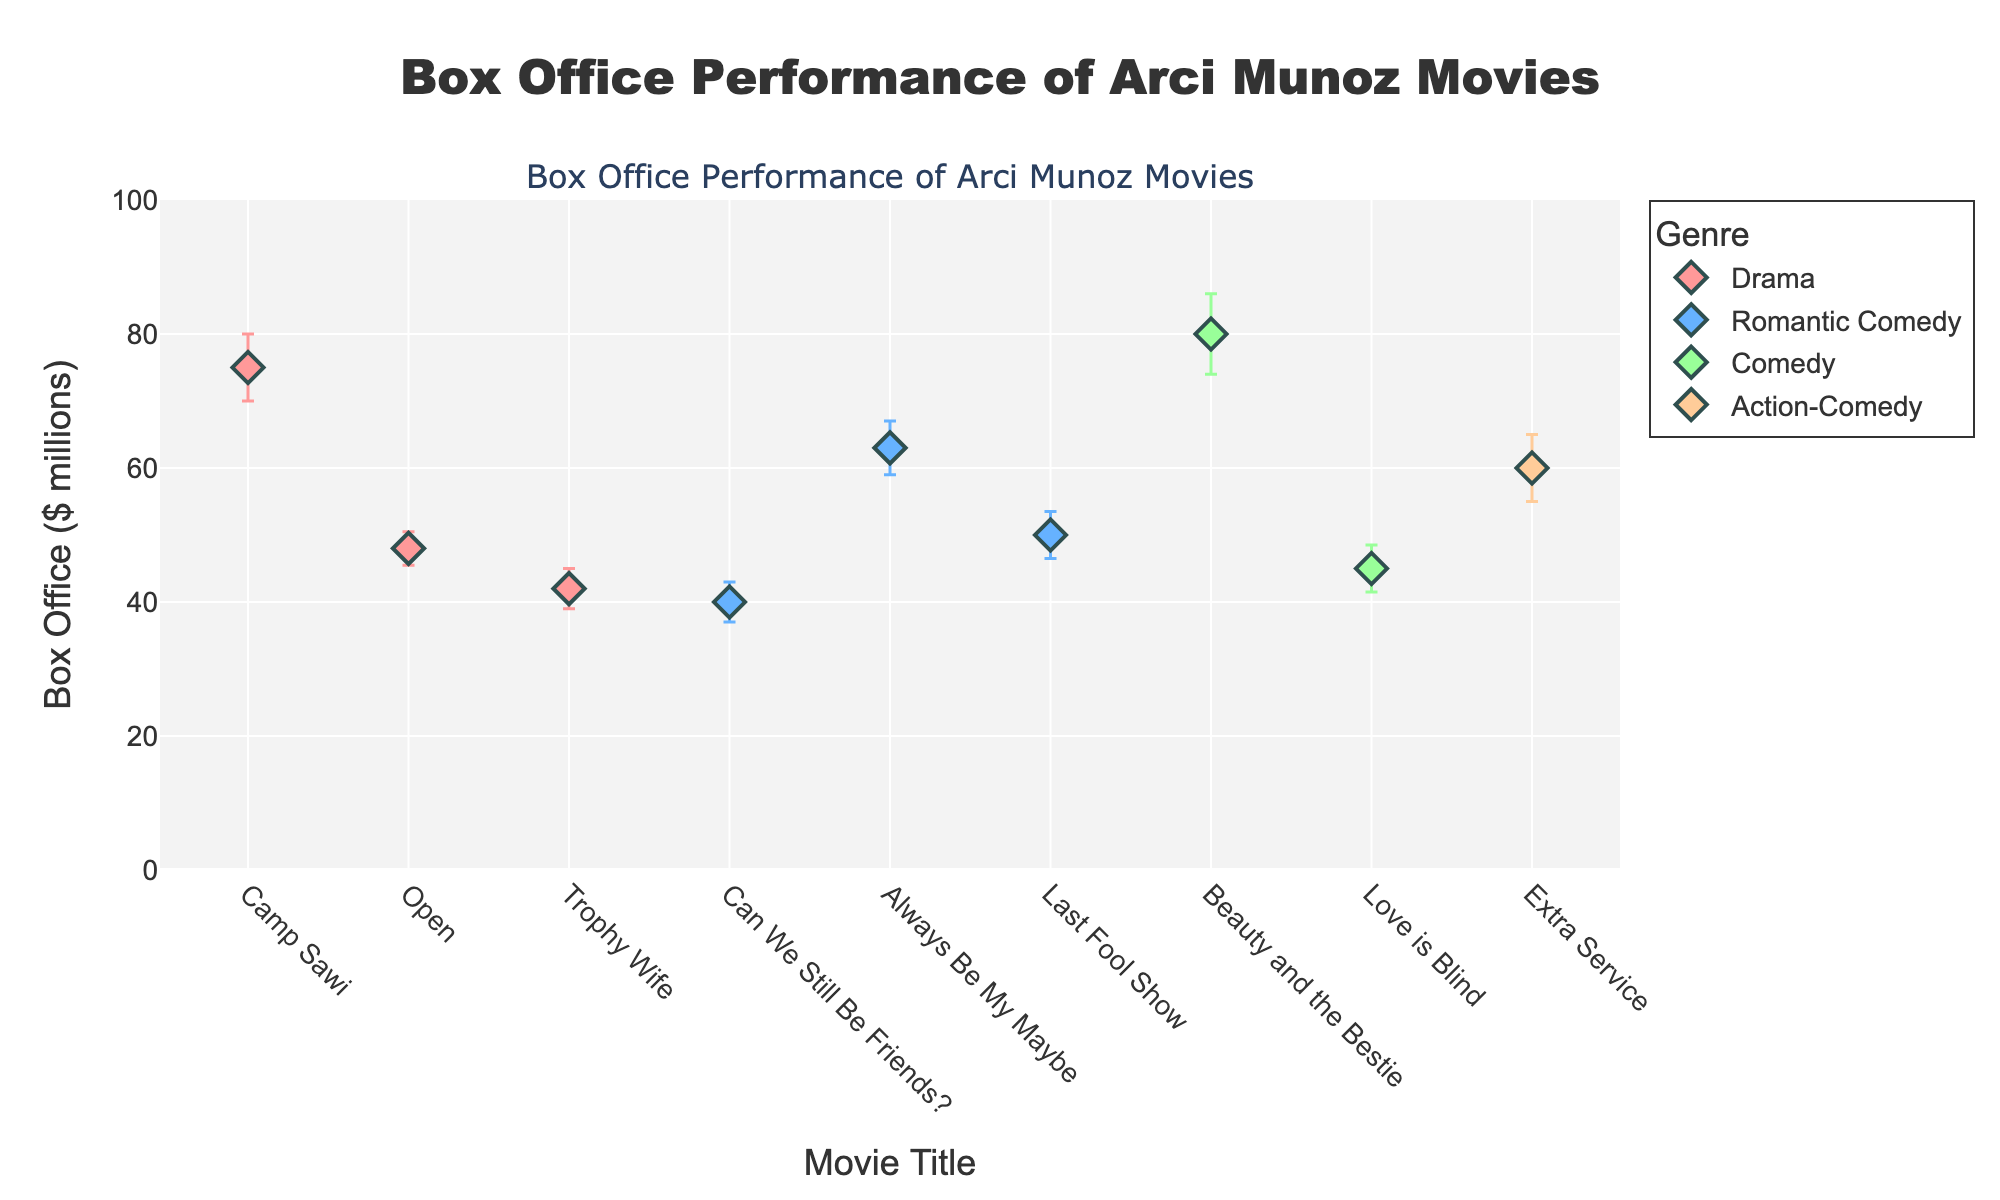What is the title of the figure? The title of the figure is prominently displayed at the top and reads "Box Office Performance of Arci Munoz Movies".
Answer: Box Office Performance of Arci Munoz Movies How many genres are represented in the plot? By looking at the legend, we can see that there are five distinct genres represented: Drama, Romantic Comedy, Comedy, Action-Comedy, and Romantic Comedy.
Answer: Five Which movie has the highest box office revenue and what genre is it? The highest point on the y-axis identifies the movie with the highest box office revenue. "Beauty and the Bestie" has the highest revenue at $80 million and belongs to the Comedy genre.
Answer: Beauty and the Bestie, Comedy What is the box office revenue for "Trophy Wife" and its error margin? From the "Trophy Wife" marker, we observe that the box office revenue is $42 million and the error margin is $3 million, as indicated by the error bar.
Answer: $42 million, $3 million Which genre has the most movies listed in the plot? Evaluating the legend and markers, we see that Romantic Comedy has the most movies listed: "Can We Still Be Friends?", "Always Be My Maybe", and "Last Fool Show".
Answer: Romantic Comedy What is the difference in box office revenue between "Camp Sawi" and "Open"? Checking the markers, "Camp Sawi" has $75 million and "Open" has $48 million in revenue. The difference is $75 million - $48 million = $27 million.
Answer: $27 million Which movie has the largest error margin and how much is it? By looking at the error bars, "Beauty and the Bestie" has the largest error margin of $6 million.
Answer: Beauty and the Bestie, $6 million Arrange the Comedy movies in ascending order of their box office revenue. Looking at the markers for Comedy: "Love is Blind" ($45 million) and "Beauty and the Bestie" ($80 million), the ascending order is "Love is Blind", "Beauty and the Bestie".
Answer: Love is Blind, Beauty and the Bestie What is the average box office revenue for Drama genre movies depicted in the plot? The movies in the Drama genre are "Camp Sawi" ($75 million), "Open" ($48 million), and "Trophy Wife" ($42 million). The average is (75 + 48 + 42) / 3 = $55 million.
Answer: $55 million Which Action-Comedy movie is in the plot and what is its box office revenue? There is only one Action-Comedy movie in the plot, "Extra Service", which has a box office revenue of $60 million.
Answer: Extra Service, $60 million 